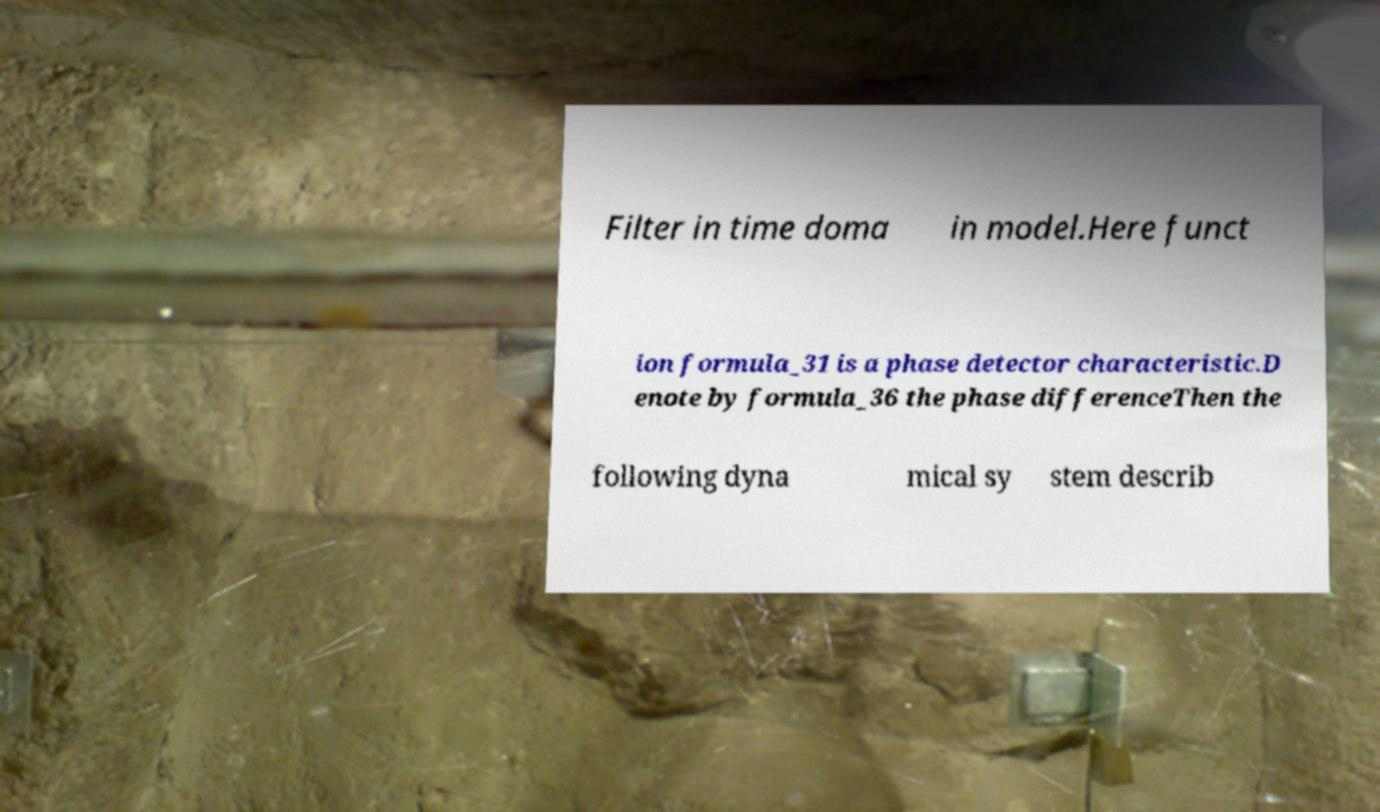Could you extract and type out the text from this image? Filter in time doma in model.Here funct ion formula_31 is a phase detector characteristic.D enote by formula_36 the phase differenceThen the following dyna mical sy stem describ 